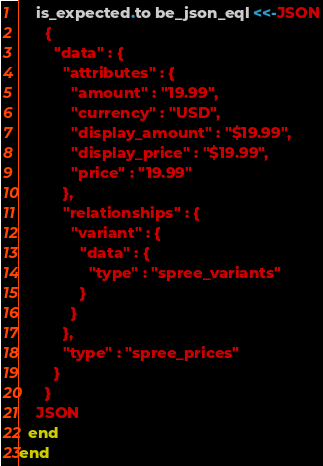<code> <loc_0><loc_0><loc_500><loc_500><_Ruby_>    is_expected.to be_json_eql <<-JSON
      {
        "data" : {
          "attributes" : {
            "amount" : "19.99",
            "currency" : "USD",
            "display_amount" : "$19.99",
            "display_price" : "$19.99",
            "price" : "19.99"
          },
          "relationships" : {
            "variant" : {
              "data" : {
                "type" : "spree_variants"
              }
            }
          },
          "type" : "spree_prices"
        }
      }
    JSON
  end
end
</code> 